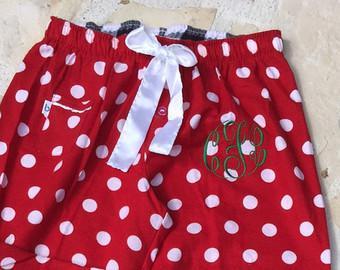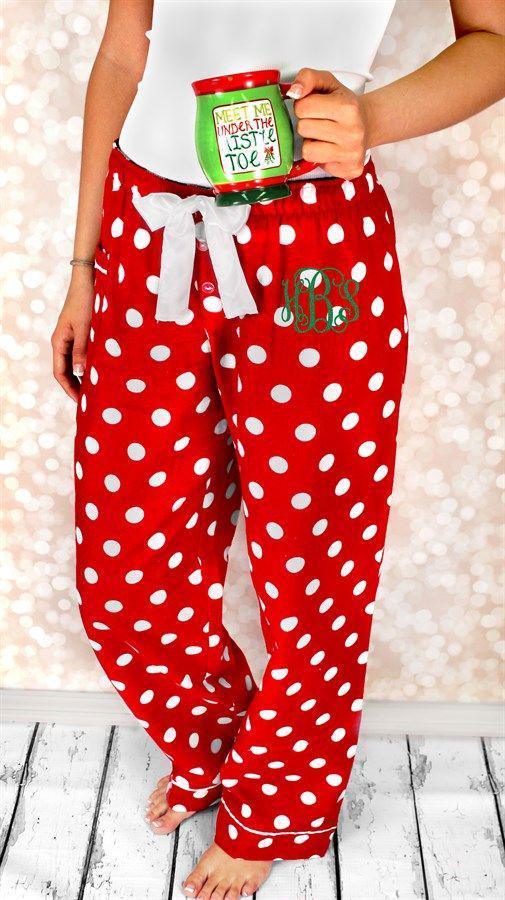The first image is the image on the left, the second image is the image on the right. For the images displayed, is the sentence "One image shows a mostly white top paired with red pants that have white polka dots." factually correct? Answer yes or no. Yes. The first image is the image on the left, the second image is the image on the right. Considering the images on both sides, is "There is a reindeer on at least one of the shirts." valid? Answer yes or no. No. 